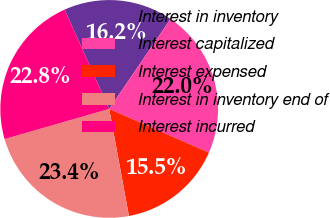<chart> <loc_0><loc_0><loc_500><loc_500><pie_chart><fcel>Interest in inventory<fcel>Interest capitalized<fcel>Interest expensed<fcel>Interest in inventory end of<fcel>Interest incurred<nl><fcel>16.23%<fcel>22.05%<fcel>15.53%<fcel>23.44%<fcel>22.75%<nl></chart> 